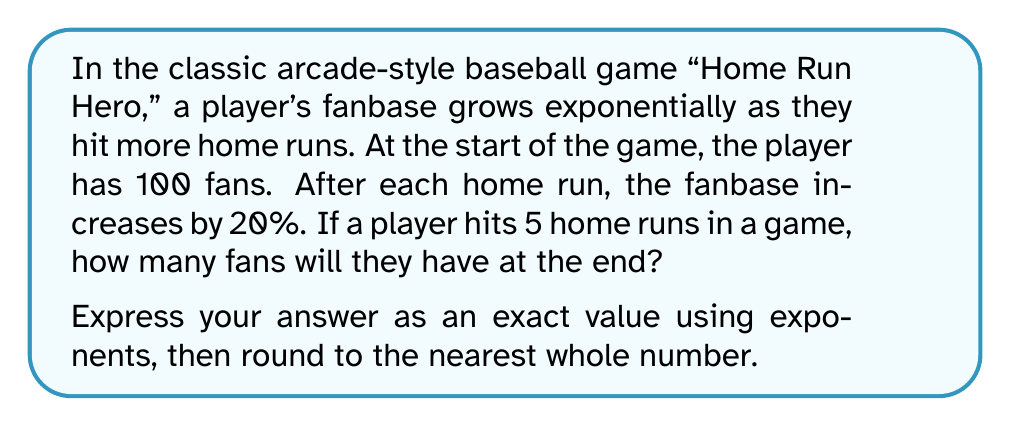Solve this math problem. Let's approach this step-by-step:

1) We start with an initial fanbase of 100.

2) After each home run, the fanbase increases by 20%, which means it's multiplied by 1.20 (or 120%).

3) This happens 5 times (for 5 home runs).

4) We can express this mathematically as:

   $$ \text{Final Fanbase} = 100 \times (1.20)^5 $$

5) Let's calculate this:

   $$ 100 \times (1.20)^5 = 100 \times 2.4883... $$

6) This equals:

   $$ 248.83... $$

7) Rounding to the nearest whole number gives us 249.

The exact value using exponents is $100 \times (1.20)^5$, and the rounded answer is 249.
Answer: Exact: $100 \times (1.20)^5$
Rounded: 249 fans 